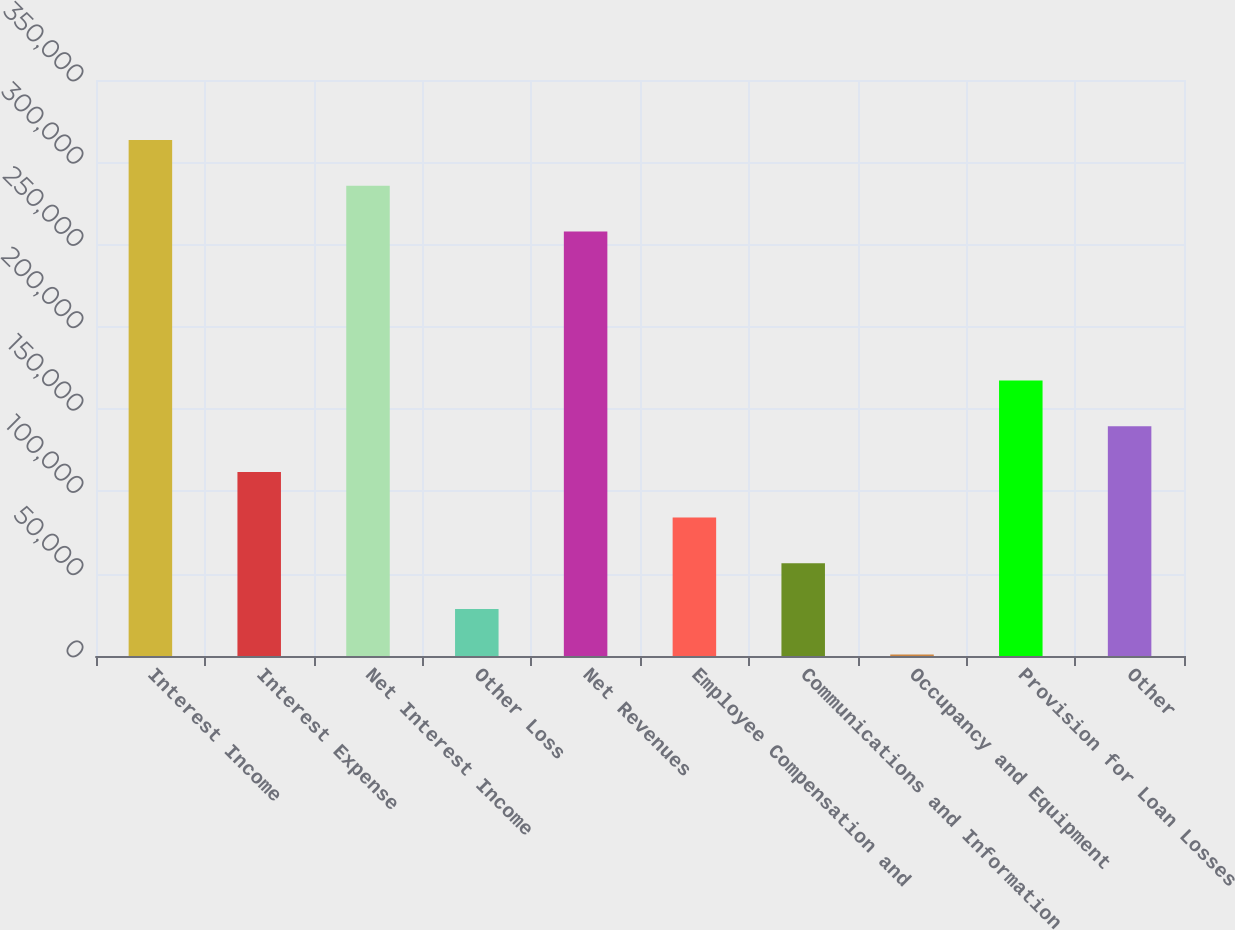<chart> <loc_0><loc_0><loc_500><loc_500><bar_chart><fcel>Interest Income<fcel>Interest Expense<fcel>Net Interest Income<fcel>Other Loss<fcel>Net Revenues<fcel>Employee Compensation and<fcel>Communications and Information<fcel>Occupancy and Equipment<fcel>Provision for Loan Losses<fcel>Other<nl><fcel>313500<fcel>111854<fcel>285754<fcel>28618.3<fcel>258009<fcel>84108.9<fcel>56363.6<fcel>873<fcel>167345<fcel>139600<nl></chart> 